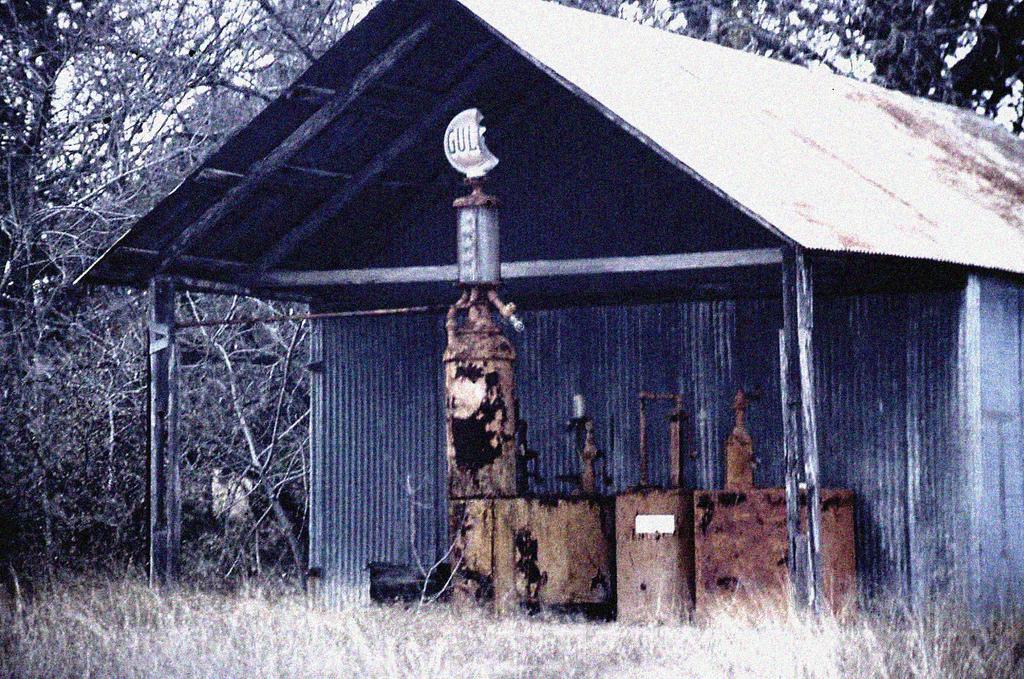Can you describe this image briefly? In this image we can see there is a shed and in front of the shed there is an object looks like a machine. And there is grass and trees. 